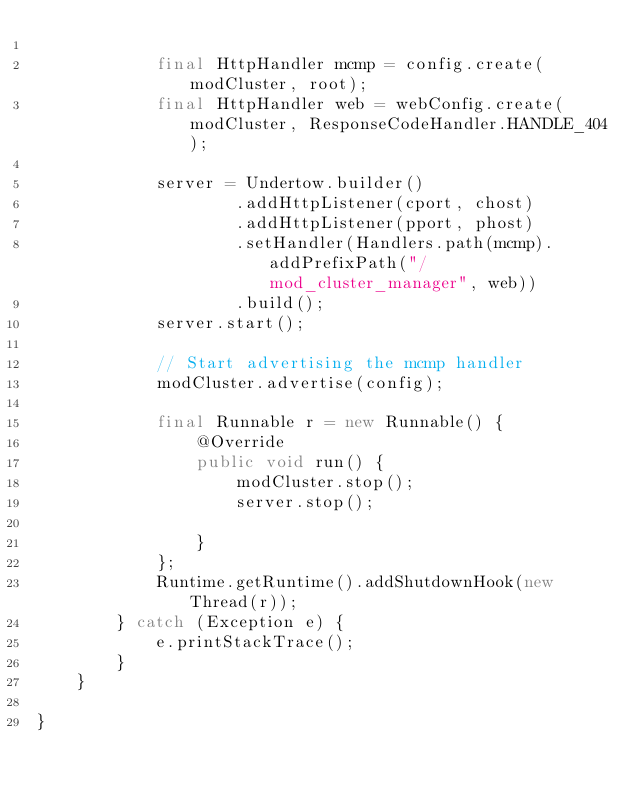Convert code to text. <code><loc_0><loc_0><loc_500><loc_500><_Java_>
            final HttpHandler mcmp = config.create(modCluster, root);
            final HttpHandler web = webConfig.create(modCluster, ResponseCodeHandler.HANDLE_404);

            server = Undertow.builder()
                    .addHttpListener(cport, chost)
                    .addHttpListener(pport, phost)
                    .setHandler(Handlers.path(mcmp).addPrefixPath("/mod_cluster_manager", web))
                    .build();
            server.start();

            // Start advertising the mcmp handler
            modCluster.advertise(config);

            final Runnable r = new Runnable() {
                @Override
                public void run() {
                    modCluster.stop();
                    server.stop();

                }
            };
            Runtime.getRuntime().addShutdownHook(new Thread(r));
        } catch (Exception e) {
            e.printStackTrace();
        }
    }

}
</code> 